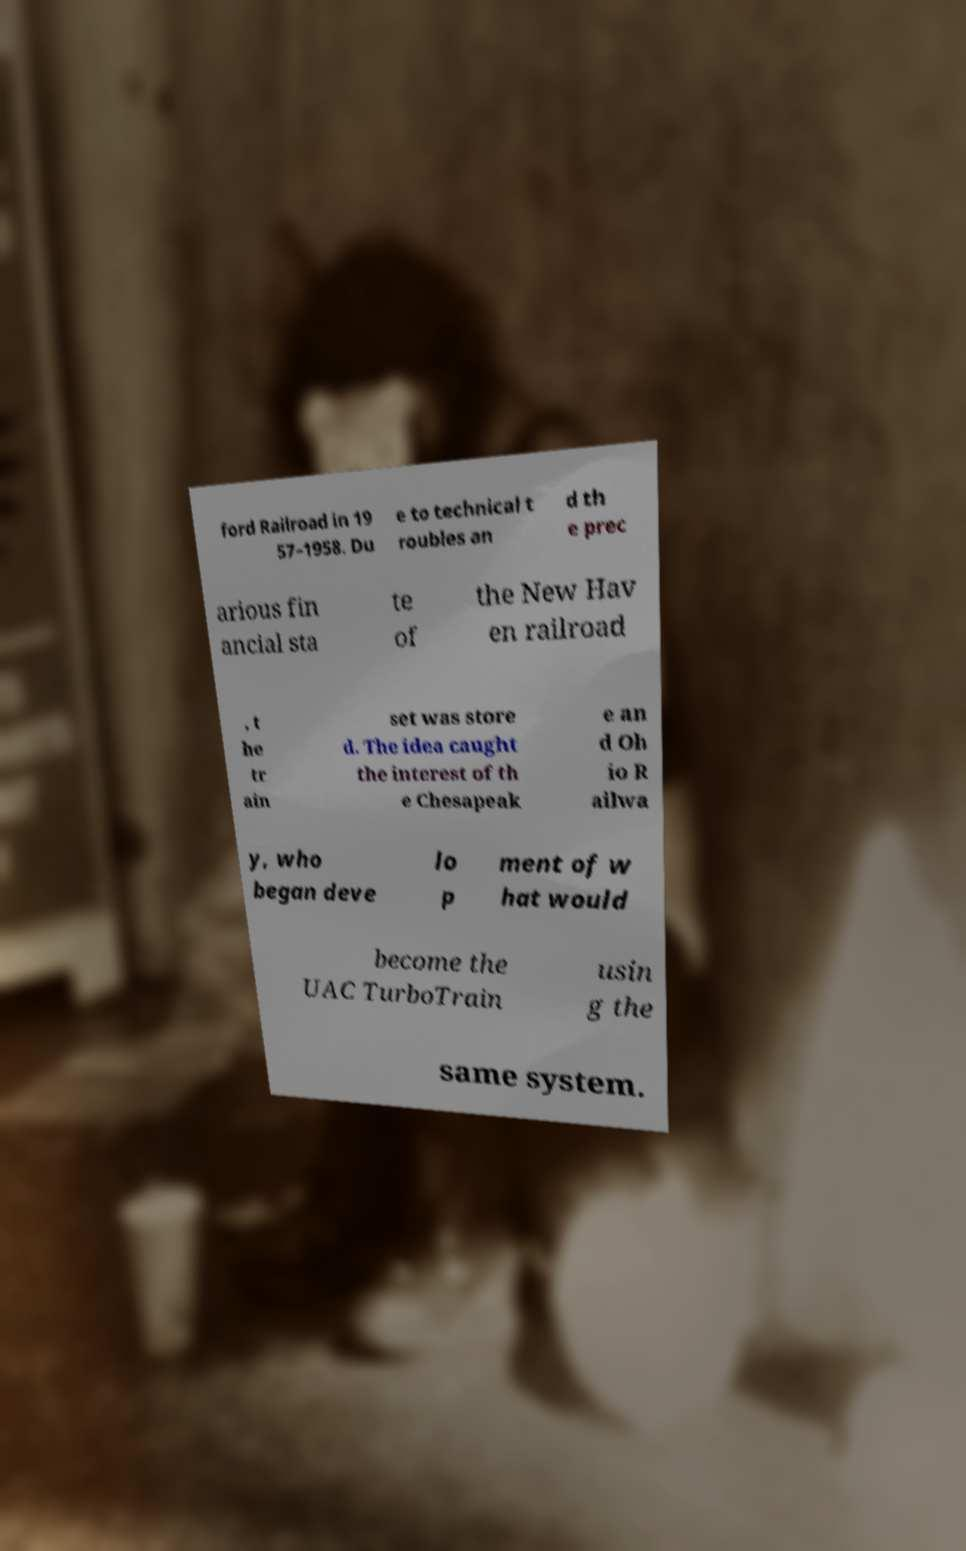Please read and relay the text visible in this image. What does it say? ford Railroad in 19 57–1958. Du e to technical t roubles an d th e prec arious fin ancial sta te of the New Hav en railroad , t he tr ain set was store d. The idea caught the interest of th e Chesapeak e an d Oh io R ailwa y, who began deve lo p ment of w hat would become the UAC TurboTrain usin g the same system. 